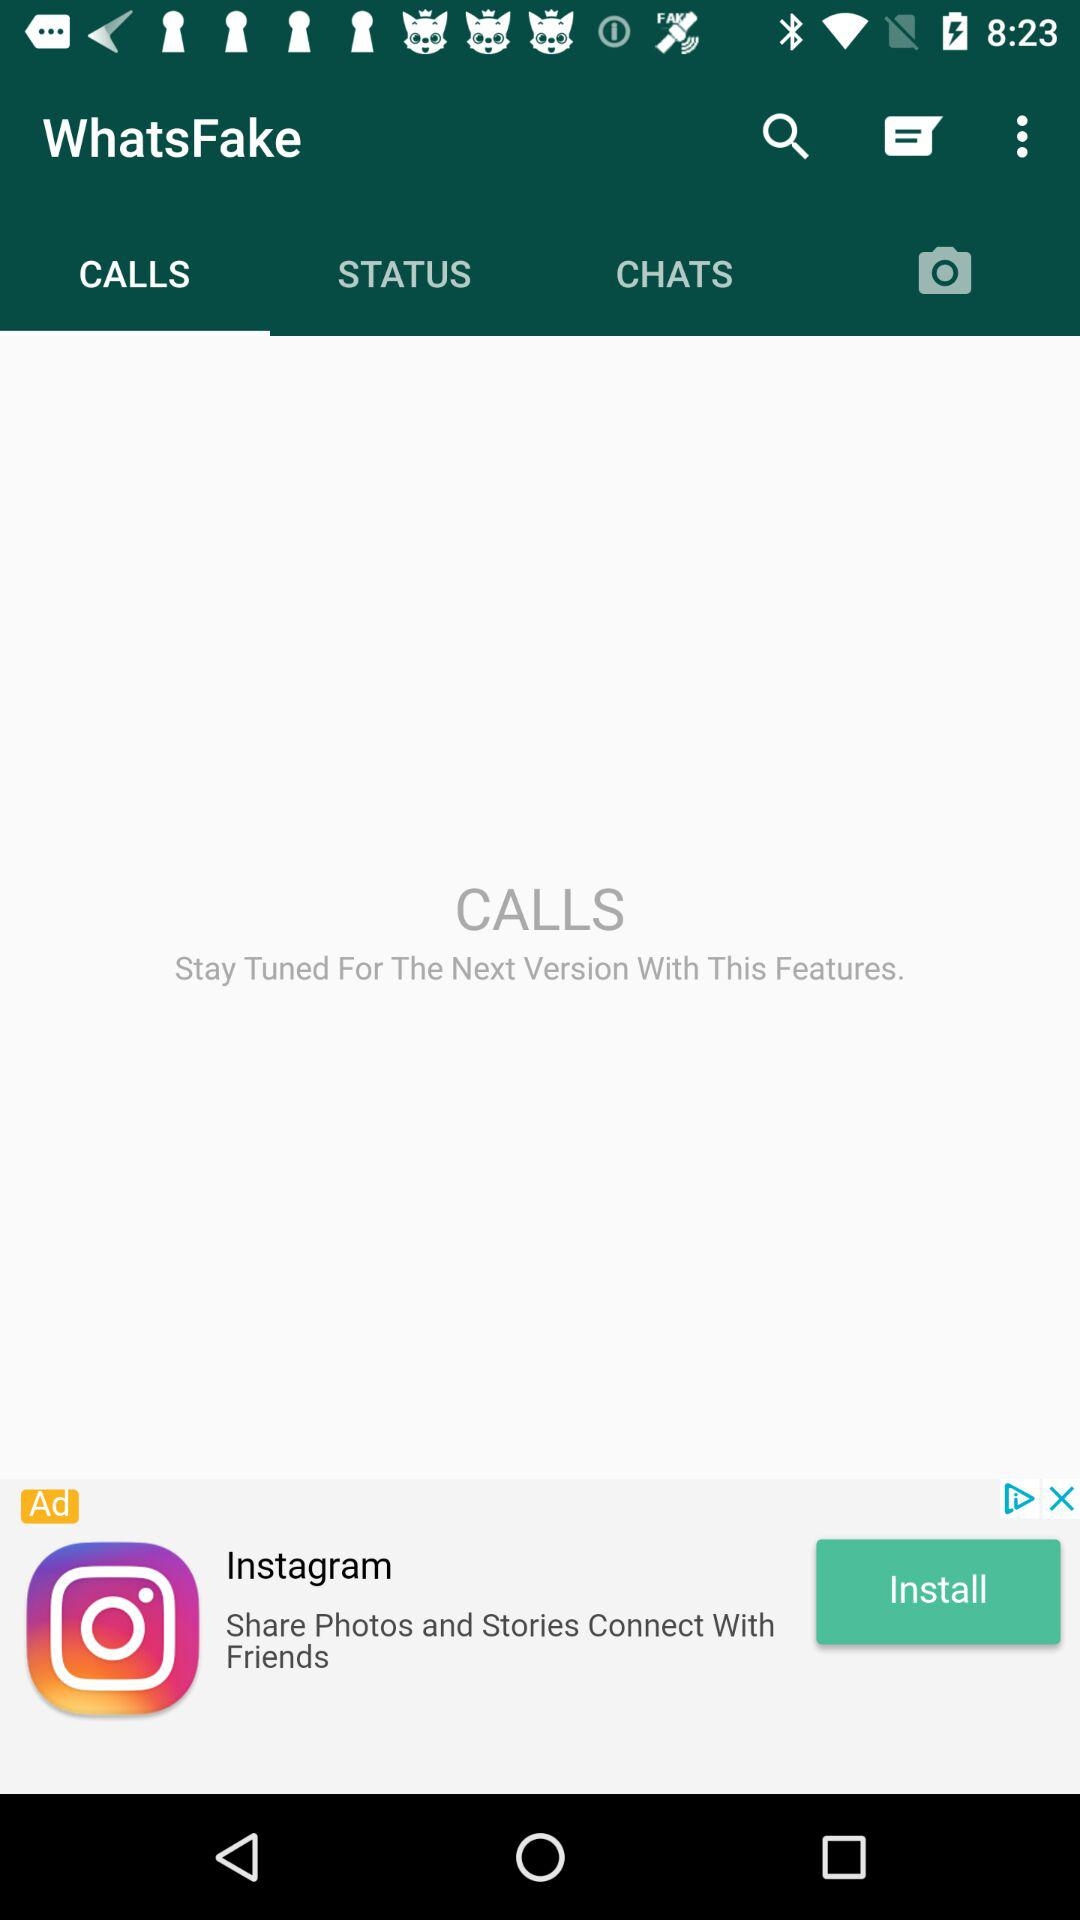How many chats are open?
When the provided information is insufficient, respond with <no answer>. <no answer> 